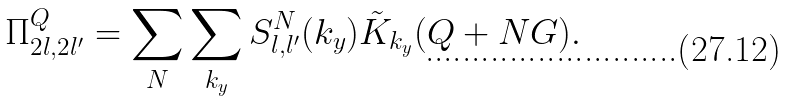<formula> <loc_0><loc_0><loc_500><loc_500>\Pi ^ { Q } _ { 2 l , 2 l ^ { \prime } } = \sum _ { N } \sum _ { k _ { y } } S ^ { N } _ { l , l ^ { \prime } } ( k _ { y } ) \tilde { K } _ { k _ { y } } ( Q + N G ) .</formula> 